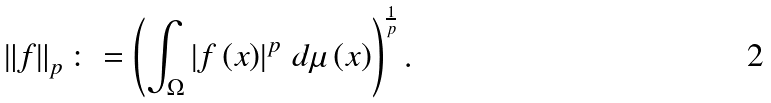<formula> <loc_0><loc_0><loc_500><loc_500>\left \| { f } \right \| _ { p } \colon = \left ( \int _ { \Omega } \left | { f } \left ( x \right ) \right | ^ { p } \, { d \mu \left ( x \right ) } \right ) ^ { \frac { 1 } { p } } .</formula> 